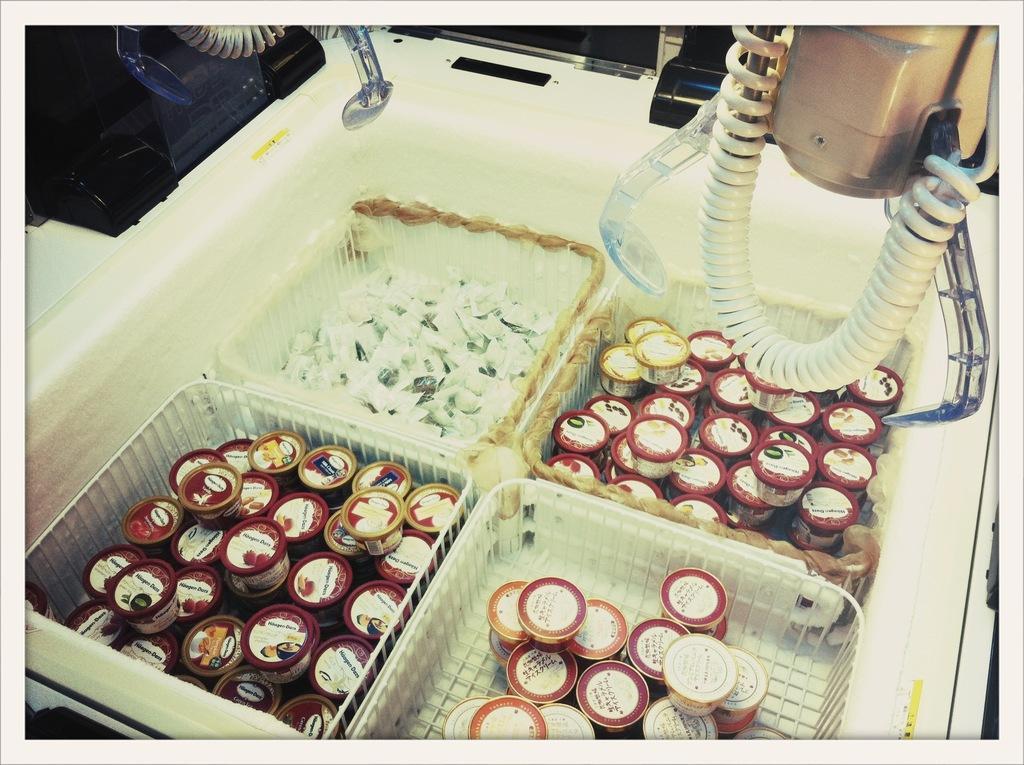In one or two sentences, can you explain what this image depicts? In this image I can see small containers looking like ice cream cups in four baskets. One among the baskets is holding another item than ice cream cups. These four baskets are kept in an ice-cream refrigerator. At the top of the image I can see some electrical devices. 